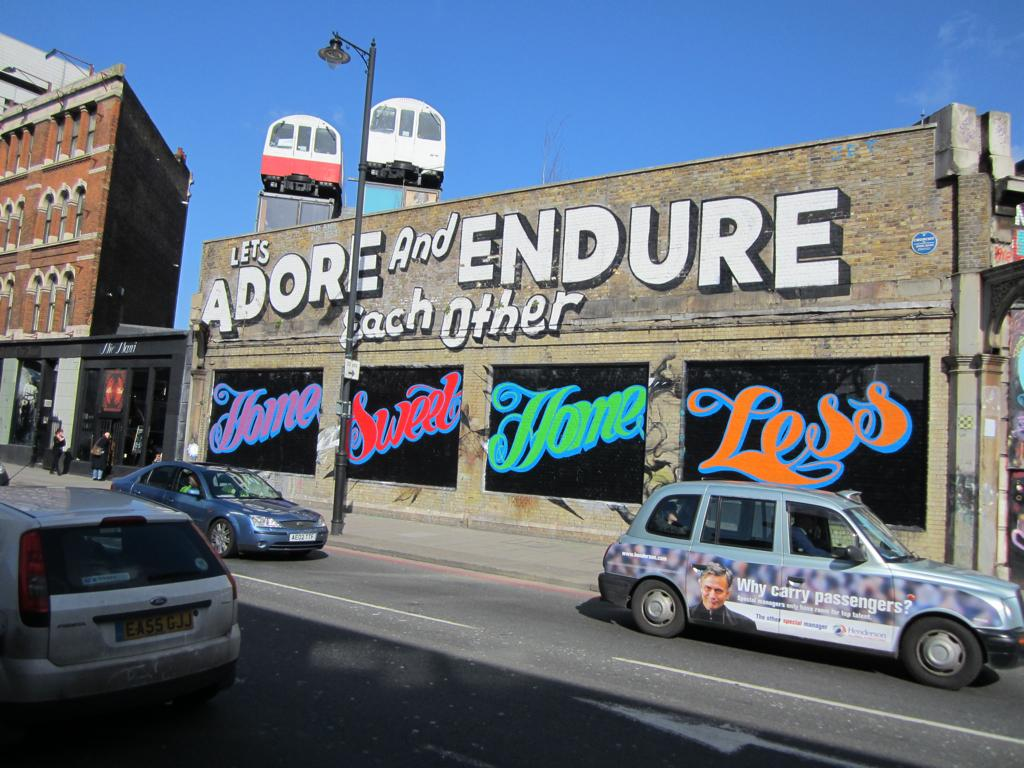<image>
Summarize the visual content of the image. An artistic sign painted on the side of a building encouraging people to "Adore and Endure Each Other". 